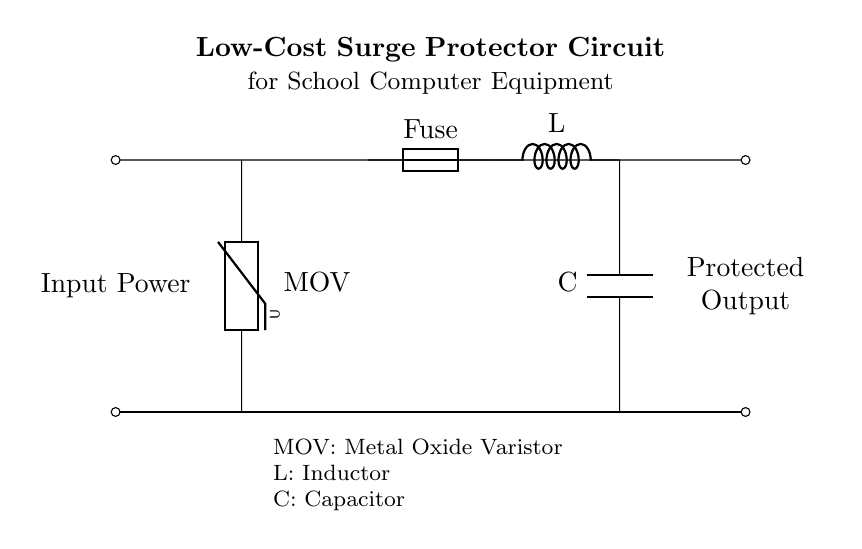What is the main function of the MOV? The MOV, or Metal Oxide Varistor, is meant to protect circuits by clamping voltage spikes. It acts as a voltage-dependent resistor that limits the voltage across the components in the circuit, thereby safeguarding against surges.
Answer: Metal Oxide Varistor Which component is used for overcurrent protection? The fuse is designed to provide overcurrent protection. It is a safety device that allows current to flow under normal conditions but melts and breaks the circuit in the event of excessive current, thus preventing damage.
Answer: Fuse What does the capacitor do in this circuit? The capacitor is used to smooth out voltage fluctuations and filter noise in the circuit. It stores energy and releases it when needed, which helps to stabilize the output voltage.
Answer: Stabilizes voltage What is the value of the inductor in this circuit? The circuit diagram does not specify the numerical value of the inductor; it is simply labeled "L." The value would typically depend on the design requirements and intended frequency characteristics of the application.
Answer: Not specified How does the surge protector circuit protect the computer equipment? The surge protector circuit utilizes the MOV to clamp voltage spikes, while the fuse prevents overcurrent, and the inductor and capacitor work together to filter and stabilize the power supply, ensuring safe operation for the computer equipment.
Answer: Through clamping, overcurrent protection, and stabilization Which two types of components comprise the filtering elements? The filtering elements in the circuit consist of the inductor and capacitor. These components work together to remove unwanted high-frequency noise and smooth out voltage variations at the output.
Answer: Inductor and capacitor 